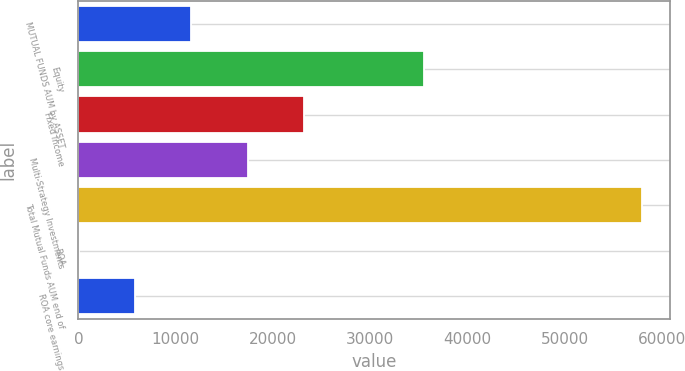Convert chart. <chart><loc_0><loc_0><loc_500><loc_500><bar_chart><fcel>MUTUAL FUNDS AUM by ASSET<fcel>Equity<fcel>Fixed Income<fcel>Multi-Strategy Investments<fcel>Total Mutual Funds AUM end of<fcel>ROA<fcel>ROA core earnings<nl><fcel>11593.4<fcel>35489<fcel>23176.3<fcel>17384.8<fcel>57925<fcel>10.5<fcel>5801.95<nl></chart> 